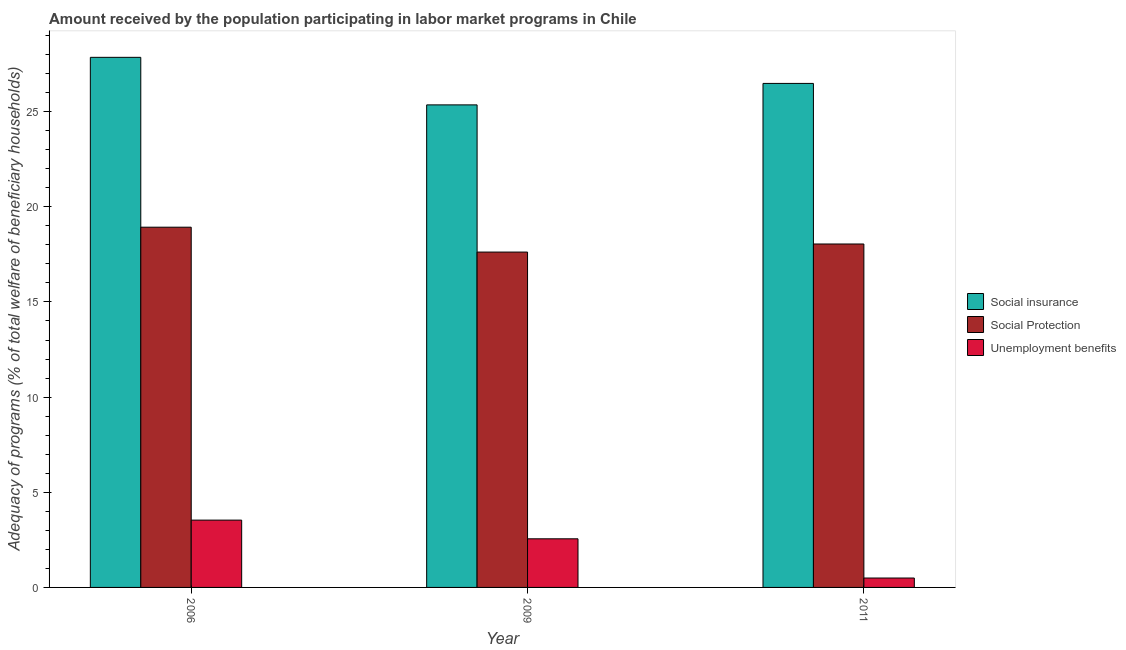How many different coloured bars are there?
Offer a very short reply. 3. How many groups of bars are there?
Make the answer very short. 3. How many bars are there on the 2nd tick from the right?
Make the answer very short. 3. In how many cases, is the number of bars for a given year not equal to the number of legend labels?
Your answer should be very brief. 0. What is the amount received by the population participating in social insurance programs in 2006?
Your answer should be compact. 27.85. Across all years, what is the maximum amount received by the population participating in social insurance programs?
Your response must be concise. 27.85. Across all years, what is the minimum amount received by the population participating in unemployment benefits programs?
Keep it short and to the point. 0.49. In which year was the amount received by the population participating in social insurance programs maximum?
Keep it short and to the point. 2006. In which year was the amount received by the population participating in unemployment benefits programs minimum?
Provide a succinct answer. 2011. What is the total amount received by the population participating in unemployment benefits programs in the graph?
Make the answer very short. 6.59. What is the difference between the amount received by the population participating in social insurance programs in 2006 and that in 2011?
Provide a succinct answer. 1.37. What is the difference between the amount received by the population participating in unemployment benefits programs in 2006 and the amount received by the population participating in social protection programs in 2009?
Provide a short and direct response. 0.98. What is the average amount received by the population participating in unemployment benefits programs per year?
Offer a very short reply. 2.2. In how many years, is the amount received by the population participating in social insurance programs greater than 23 %?
Your response must be concise. 3. What is the ratio of the amount received by the population participating in social protection programs in 2009 to that in 2011?
Offer a very short reply. 0.98. Is the difference between the amount received by the population participating in social insurance programs in 2006 and 2009 greater than the difference between the amount received by the population participating in unemployment benefits programs in 2006 and 2009?
Keep it short and to the point. No. What is the difference between the highest and the second highest amount received by the population participating in social protection programs?
Your answer should be compact. 0.88. What is the difference between the highest and the lowest amount received by the population participating in unemployment benefits programs?
Ensure brevity in your answer.  3.04. In how many years, is the amount received by the population participating in unemployment benefits programs greater than the average amount received by the population participating in unemployment benefits programs taken over all years?
Your answer should be compact. 2. Is the sum of the amount received by the population participating in social insurance programs in 2006 and 2011 greater than the maximum amount received by the population participating in social protection programs across all years?
Keep it short and to the point. Yes. What does the 3rd bar from the left in 2006 represents?
Provide a succinct answer. Unemployment benefits. What does the 1st bar from the right in 2011 represents?
Your response must be concise. Unemployment benefits. How many bars are there?
Give a very brief answer. 9. How many years are there in the graph?
Ensure brevity in your answer.  3. What is the difference between two consecutive major ticks on the Y-axis?
Give a very brief answer. 5. Are the values on the major ticks of Y-axis written in scientific E-notation?
Provide a short and direct response. No. Does the graph contain any zero values?
Make the answer very short. No. Does the graph contain grids?
Make the answer very short. No. How many legend labels are there?
Your response must be concise. 3. What is the title of the graph?
Make the answer very short. Amount received by the population participating in labor market programs in Chile. What is the label or title of the Y-axis?
Your response must be concise. Adequacy of programs (% of total welfare of beneficiary households). What is the Adequacy of programs (% of total welfare of beneficiary households) of Social insurance in 2006?
Give a very brief answer. 27.85. What is the Adequacy of programs (% of total welfare of beneficiary households) of Social Protection in 2006?
Provide a succinct answer. 18.93. What is the Adequacy of programs (% of total welfare of beneficiary households) of Unemployment benefits in 2006?
Give a very brief answer. 3.54. What is the Adequacy of programs (% of total welfare of beneficiary households) of Social insurance in 2009?
Ensure brevity in your answer.  25.36. What is the Adequacy of programs (% of total welfare of beneficiary households) in Social Protection in 2009?
Provide a succinct answer. 17.62. What is the Adequacy of programs (% of total welfare of beneficiary households) in Unemployment benefits in 2009?
Provide a succinct answer. 2.55. What is the Adequacy of programs (% of total welfare of beneficiary households) in Social insurance in 2011?
Give a very brief answer. 26.48. What is the Adequacy of programs (% of total welfare of beneficiary households) in Social Protection in 2011?
Ensure brevity in your answer.  18.05. What is the Adequacy of programs (% of total welfare of beneficiary households) in Unemployment benefits in 2011?
Provide a succinct answer. 0.49. Across all years, what is the maximum Adequacy of programs (% of total welfare of beneficiary households) of Social insurance?
Offer a very short reply. 27.85. Across all years, what is the maximum Adequacy of programs (% of total welfare of beneficiary households) in Social Protection?
Ensure brevity in your answer.  18.93. Across all years, what is the maximum Adequacy of programs (% of total welfare of beneficiary households) in Unemployment benefits?
Make the answer very short. 3.54. Across all years, what is the minimum Adequacy of programs (% of total welfare of beneficiary households) of Social insurance?
Ensure brevity in your answer.  25.36. Across all years, what is the minimum Adequacy of programs (% of total welfare of beneficiary households) in Social Protection?
Offer a very short reply. 17.62. Across all years, what is the minimum Adequacy of programs (% of total welfare of beneficiary households) of Unemployment benefits?
Your response must be concise. 0.49. What is the total Adequacy of programs (% of total welfare of beneficiary households) of Social insurance in the graph?
Your response must be concise. 79.69. What is the total Adequacy of programs (% of total welfare of beneficiary households) of Social Protection in the graph?
Offer a terse response. 54.59. What is the total Adequacy of programs (% of total welfare of beneficiary households) of Unemployment benefits in the graph?
Provide a succinct answer. 6.59. What is the difference between the Adequacy of programs (% of total welfare of beneficiary households) in Social insurance in 2006 and that in 2009?
Your answer should be compact. 2.5. What is the difference between the Adequacy of programs (% of total welfare of beneficiary households) of Social Protection in 2006 and that in 2009?
Your response must be concise. 1.31. What is the difference between the Adequacy of programs (% of total welfare of beneficiary households) of Unemployment benefits in 2006 and that in 2009?
Your answer should be compact. 0.98. What is the difference between the Adequacy of programs (% of total welfare of beneficiary households) in Social insurance in 2006 and that in 2011?
Your answer should be very brief. 1.37. What is the difference between the Adequacy of programs (% of total welfare of beneficiary households) in Social Protection in 2006 and that in 2011?
Keep it short and to the point. 0.88. What is the difference between the Adequacy of programs (% of total welfare of beneficiary households) of Unemployment benefits in 2006 and that in 2011?
Offer a terse response. 3.04. What is the difference between the Adequacy of programs (% of total welfare of beneficiary households) of Social insurance in 2009 and that in 2011?
Keep it short and to the point. -1.13. What is the difference between the Adequacy of programs (% of total welfare of beneficiary households) of Social Protection in 2009 and that in 2011?
Provide a short and direct response. -0.42. What is the difference between the Adequacy of programs (% of total welfare of beneficiary households) of Unemployment benefits in 2009 and that in 2011?
Your answer should be very brief. 2.06. What is the difference between the Adequacy of programs (% of total welfare of beneficiary households) of Social insurance in 2006 and the Adequacy of programs (% of total welfare of beneficiary households) of Social Protection in 2009?
Provide a succinct answer. 10.23. What is the difference between the Adequacy of programs (% of total welfare of beneficiary households) in Social insurance in 2006 and the Adequacy of programs (% of total welfare of beneficiary households) in Unemployment benefits in 2009?
Keep it short and to the point. 25.3. What is the difference between the Adequacy of programs (% of total welfare of beneficiary households) in Social Protection in 2006 and the Adequacy of programs (% of total welfare of beneficiary households) in Unemployment benefits in 2009?
Offer a terse response. 16.37. What is the difference between the Adequacy of programs (% of total welfare of beneficiary households) of Social insurance in 2006 and the Adequacy of programs (% of total welfare of beneficiary households) of Social Protection in 2011?
Your response must be concise. 9.81. What is the difference between the Adequacy of programs (% of total welfare of beneficiary households) in Social insurance in 2006 and the Adequacy of programs (% of total welfare of beneficiary households) in Unemployment benefits in 2011?
Your answer should be very brief. 27.36. What is the difference between the Adequacy of programs (% of total welfare of beneficiary households) in Social Protection in 2006 and the Adequacy of programs (% of total welfare of beneficiary households) in Unemployment benefits in 2011?
Offer a very short reply. 18.43. What is the difference between the Adequacy of programs (% of total welfare of beneficiary households) in Social insurance in 2009 and the Adequacy of programs (% of total welfare of beneficiary households) in Social Protection in 2011?
Your answer should be very brief. 7.31. What is the difference between the Adequacy of programs (% of total welfare of beneficiary households) in Social insurance in 2009 and the Adequacy of programs (% of total welfare of beneficiary households) in Unemployment benefits in 2011?
Offer a terse response. 24.86. What is the difference between the Adequacy of programs (% of total welfare of beneficiary households) in Social Protection in 2009 and the Adequacy of programs (% of total welfare of beneficiary households) in Unemployment benefits in 2011?
Provide a short and direct response. 17.13. What is the average Adequacy of programs (% of total welfare of beneficiary households) in Social insurance per year?
Provide a succinct answer. 26.56. What is the average Adequacy of programs (% of total welfare of beneficiary households) of Social Protection per year?
Your answer should be very brief. 18.2. What is the average Adequacy of programs (% of total welfare of beneficiary households) in Unemployment benefits per year?
Provide a short and direct response. 2.2. In the year 2006, what is the difference between the Adequacy of programs (% of total welfare of beneficiary households) of Social insurance and Adequacy of programs (% of total welfare of beneficiary households) of Social Protection?
Keep it short and to the point. 8.93. In the year 2006, what is the difference between the Adequacy of programs (% of total welfare of beneficiary households) of Social insurance and Adequacy of programs (% of total welfare of beneficiary households) of Unemployment benefits?
Your answer should be very brief. 24.32. In the year 2006, what is the difference between the Adequacy of programs (% of total welfare of beneficiary households) of Social Protection and Adequacy of programs (% of total welfare of beneficiary households) of Unemployment benefits?
Offer a very short reply. 15.39. In the year 2009, what is the difference between the Adequacy of programs (% of total welfare of beneficiary households) in Social insurance and Adequacy of programs (% of total welfare of beneficiary households) in Social Protection?
Ensure brevity in your answer.  7.73. In the year 2009, what is the difference between the Adequacy of programs (% of total welfare of beneficiary households) of Social insurance and Adequacy of programs (% of total welfare of beneficiary households) of Unemployment benefits?
Your answer should be very brief. 22.8. In the year 2009, what is the difference between the Adequacy of programs (% of total welfare of beneficiary households) of Social Protection and Adequacy of programs (% of total welfare of beneficiary households) of Unemployment benefits?
Your answer should be very brief. 15.07. In the year 2011, what is the difference between the Adequacy of programs (% of total welfare of beneficiary households) of Social insurance and Adequacy of programs (% of total welfare of beneficiary households) of Social Protection?
Provide a succinct answer. 8.44. In the year 2011, what is the difference between the Adequacy of programs (% of total welfare of beneficiary households) of Social insurance and Adequacy of programs (% of total welfare of beneficiary households) of Unemployment benefits?
Make the answer very short. 25.99. In the year 2011, what is the difference between the Adequacy of programs (% of total welfare of beneficiary households) of Social Protection and Adequacy of programs (% of total welfare of beneficiary households) of Unemployment benefits?
Give a very brief answer. 17.55. What is the ratio of the Adequacy of programs (% of total welfare of beneficiary households) of Social insurance in 2006 to that in 2009?
Make the answer very short. 1.1. What is the ratio of the Adequacy of programs (% of total welfare of beneficiary households) of Social Protection in 2006 to that in 2009?
Provide a succinct answer. 1.07. What is the ratio of the Adequacy of programs (% of total welfare of beneficiary households) in Unemployment benefits in 2006 to that in 2009?
Your answer should be compact. 1.38. What is the ratio of the Adequacy of programs (% of total welfare of beneficiary households) in Social insurance in 2006 to that in 2011?
Offer a very short reply. 1.05. What is the ratio of the Adequacy of programs (% of total welfare of beneficiary households) in Social Protection in 2006 to that in 2011?
Offer a very short reply. 1.05. What is the ratio of the Adequacy of programs (% of total welfare of beneficiary households) in Unemployment benefits in 2006 to that in 2011?
Your response must be concise. 7.16. What is the ratio of the Adequacy of programs (% of total welfare of beneficiary households) of Social insurance in 2009 to that in 2011?
Make the answer very short. 0.96. What is the ratio of the Adequacy of programs (% of total welfare of beneficiary households) of Social Protection in 2009 to that in 2011?
Ensure brevity in your answer.  0.98. What is the ratio of the Adequacy of programs (% of total welfare of beneficiary households) of Unemployment benefits in 2009 to that in 2011?
Keep it short and to the point. 5.17. What is the difference between the highest and the second highest Adequacy of programs (% of total welfare of beneficiary households) of Social insurance?
Make the answer very short. 1.37. What is the difference between the highest and the second highest Adequacy of programs (% of total welfare of beneficiary households) of Social Protection?
Offer a very short reply. 0.88. What is the difference between the highest and the second highest Adequacy of programs (% of total welfare of beneficiary households) of Unemployment benefits?
Offer a terse response. 0.98. What is the difference between the highest and the lowest Adequacy of programs (% of total welfare of beneficiary households) in Social insurance?
Offer a terse response. 2.5. What is the difference between the highest and the lowest Adequacy of programs (% of total welfare of beneficiary households) of Social Protection?
Give a very brief answer. 1.31. What is the difference between the highest and the lowest Adequacy of programs (% of total welfare of beneficiary households) of Unemployment benefits?
Give a very brief answer. 3.04. 